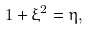<formula> <loc_0><loc_0><loc_500><loc_500>1 + \xi ^ { 2 } = \eta ,</formula> 